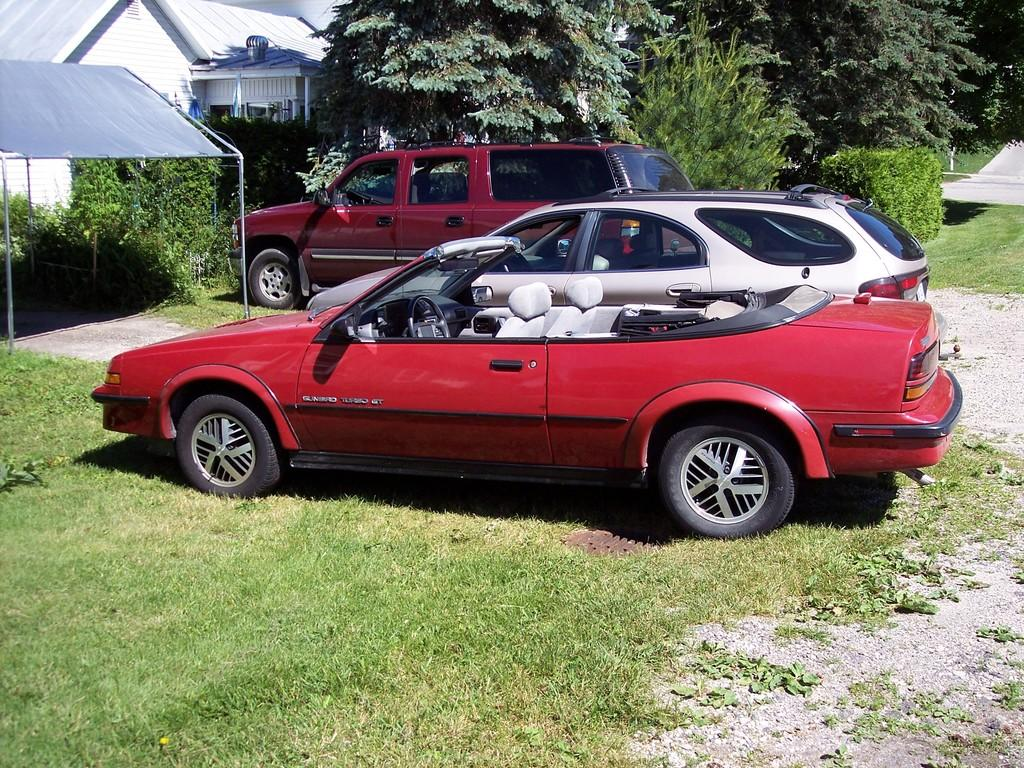What type of vegetation can be seen in the image? There is grass in the image. What else is present on the ground in the image? There are vehicles on the ground in the image. What type of shelter is visible in the image? There is a tent in the image. What type of structure is visible in the image? There is a building in the image. What else can be seen in the image besides the grass, vehicles, tent, and building? There are objects in the image. What can be seen in the background of the image? There are trees visible in the background of the image. Can you tell me how many clams are present in the image? There are no clams present in the image. What type of friction is being generated by the objects in the image? The provided facts do not mention any friction, so it cannot be determined from the image. 